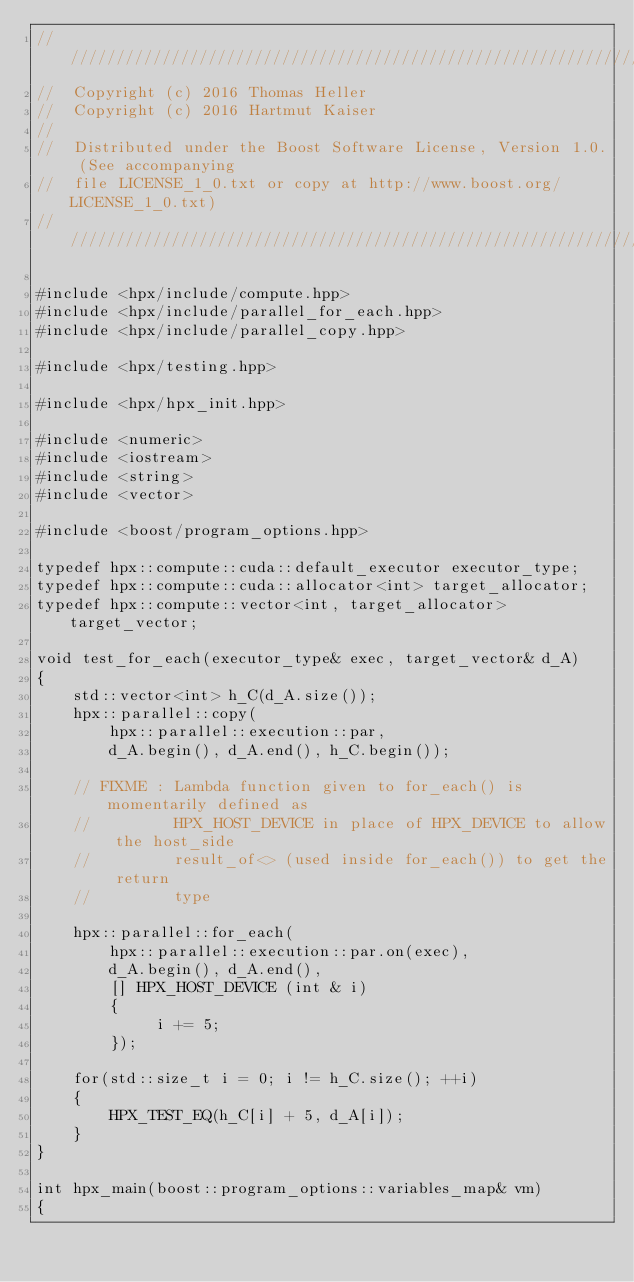<code> <loc_0><loc_0><loc_500><loc_500><_Cuda_>///////////////////////////////////////////////////////////////////////////////
//  Copyright (c) 2016 Thomas Heller
//  Copyright (c) 2016 Hartmut Kaiser
//
//  Distributed under the Boost Software License, Version 1.0. (See accompanying
//  file LICENSE_1_0.txt or copy at http://www.boost.org/LICENSE_1_0.txt)
///////////////////////////////////////////////////////////////////////////////

#include <hpx/include/compute.hpp>
#include <hpx/include/parallel_for_each.hpp>
#include <hpx/include/parallel_copy.hpp>

#include <hpx/testing.hpp>

#include <hpx/hpx_init.hpp>

#include <numeric>
#include <iostream>
#include <string>
#include <vector>

#include <boost/program_options.hpp>

typedef hpx::compute::cuda::default_executor executor_type;
typedef hpx::compute::cuda::allocator<int> target_allocator;
typedef hpx::compute::vector<int, target_allocator> target_vector;

void test_for_each(executor_type& exec, target_vector& d_A)
{
    std::vector<int> h_C(d_A.size());
    hpx::parallel::copy(
        hpx::parallel::execution::par,
        d_A.begin(), d_A.end(), h_C.begin());

    // FIXME : Lambda function given to for_each() is momentarily defined as
    //         HPX_HOST_DEVICE in place of HPX_DEVICE to allow the host_side
    //         result_of<> (used inside for_each()) to get the return
    //         type

    hpx::parallel::for_each(
        hpx::parallel::execution::par.on(exec),
        d_A.begin(), d_A.end(),
        [] HPX_HOST_DEVICE (int & i)
        {
             i += 5;
        });

    for(std::size_t i = 0; i != h_C.size(); ++i)
    {
        HPX_TEST_EQ(h_C[i] + 5, d_A[i]);
    }
}

int hpx_main(boost::program_options::variables_map& vm)
{</code> 